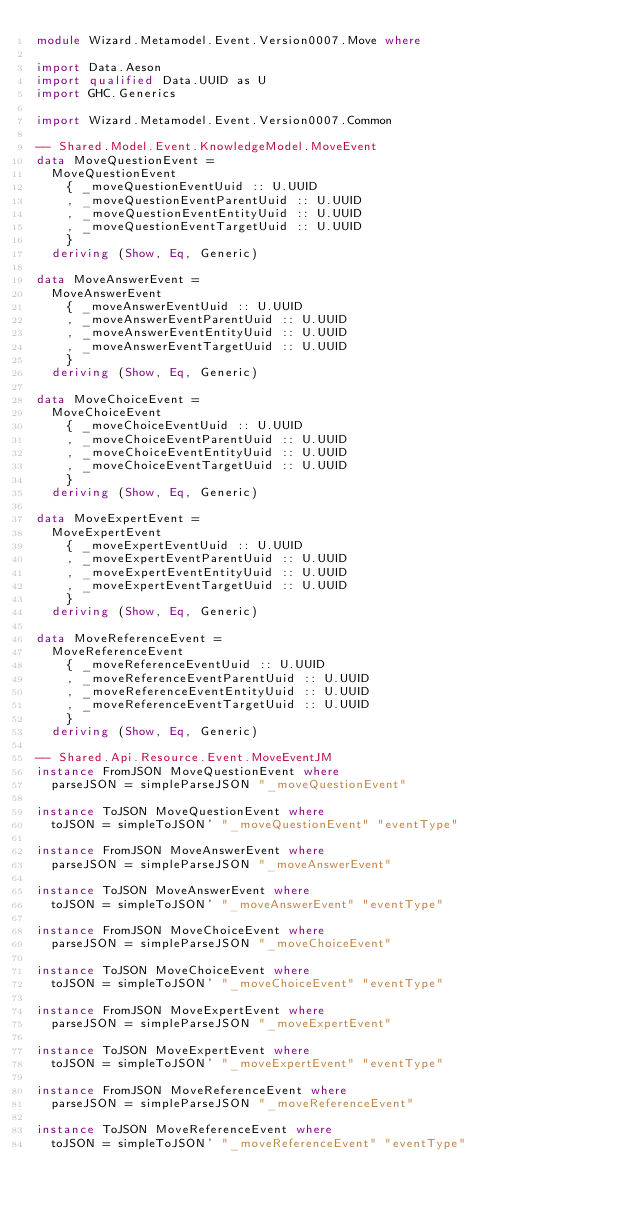Convert code to text. <code><loc_0><loc_0><loc_500><loc_500><_Haskell_>module Wizard.Metamodel.Event.Version0007.Move where

import Data.Aeson
import qualified Data.UUID as U
import GHC.Generics

import Wizard.Metamodel.Event.Version0007.Common

-- Shared.Model.Event.KnowledgeModel.MoveEvent
data MoveQuestionEvent =
  MoveQuestionEvent
    { _moveQuestionEventUuid :: U.UUID
    , _moveQuestionEventParentUuid :: U.UUID
    , _moveQuestionEventEntityUuid :: U.UUID
    , _moveQuestionEventTargetUuid :: U.UUID
    }
  deriving (Show, Eq, Generic)

data MoveAnswerEvent =
  MoveAnswerEvent
    { _moveAnswerEventUuid :: U.UUID
    , _moveAnswerEventParentUuid :: U.UUID
    , _moveAnswerEventEntityUuid :: U.UUID
    , _moveAnswerEventTargetUuid :: U.UUID
    }
  deriving (Show, Eq, Generic)

data MoveChoiceEvent =
  MoveChoiceEvent
    { _moveChoiceEventUuid :: U.UUID
    , _moveChoiceEventParentUuid :: U.UUID
    , _moveChoiceEventEntityUuid :: U.UUID
    , _moveChoiceEventTargetUuid :: U.UUID
    }
  deriving (Show, Eq, Generic)

data MoveExpertEvent =
  MoveExpertEvent
    { _moveExpertEventUuid :: U.UUID
    , _moveExpertEventParentUuid :: U.UUID
    , _moveExpertEventEntityUuid :: U.UUID
    , _moveExpertEventTargetUuid :: U.UUID
    }
  deriving (Show, Eq, Generic)

data MoveReferenceEvent =
  MoveReferenceEvent
    { _moveReferenceEventUuid :: U.UUID
    , _moveReferenceEventParentUuid :: U.UUID
    , _moveReferenceEventEntityUuid :: U.UUID
    , _moveReferenceEventTargetUuid :: U.UUID
    }
  deriving (Show, Eq, Generic)

-- Shared.Api.Resource.Event.MoveEventJM
instance FromJSON MoveQuestionEvent where
  parseJSON = simpleParseJSON "_moveQuestionEvent"

instance ToJSON MoveQuestionEvent where
  toJSON = simpleToJSON' "_moveQuestionEvent" "eventType"

instance FromJSON MoveAnswerEvent where
  parseJSON = simpleParseJSON "_moveAnswerEvent"

instance ToJSON MoveAnswerEvent where
  toJSON = simpleToJSON' "_moveAnswerEvent" "eventType"

instance FromJSON MoveChoiceEvent where
  parseJSON = simpleParseJSON "_moveChoiceEvent"

instance ToJSON MoveChoiceEvent where
  toJSON = simpleToJSON' "_moveChoiceEvent" "eventType"

instance FromJSON MoveExpertEvent where
  parseJSON = simpleParseJSON "_moveExpertEvent"

instance ToJSON MoveExpertEvent where
  toJSON = simpleToJSON' "_moveExpertEvent" "eventType"

instance FromJSON MoveReferenceEvent where
  parseJSON = simpleParseJSON "_moveReferenceEvent"

instance ToJSON MoveReferenceEvent where
  toJSON = simpleToJSON' "_moveReferenceEvent" "eventType"
</code> 